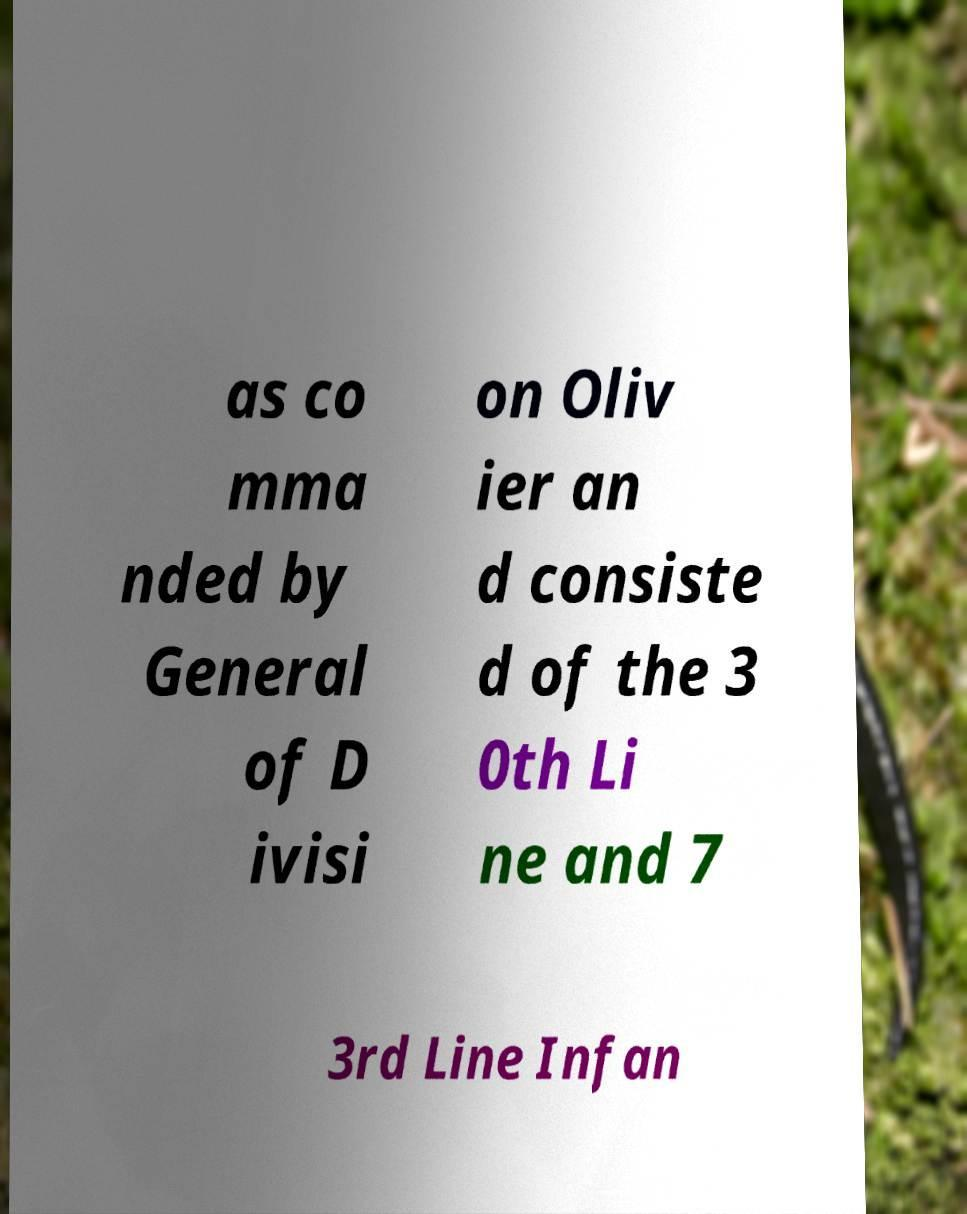I need the written content from this picture converted into text. Can you do that? as co mma nded by General of D ivisi on Oliv ier an d consiste d of the 3 0th Li ne and 7 3rd Line Infan 